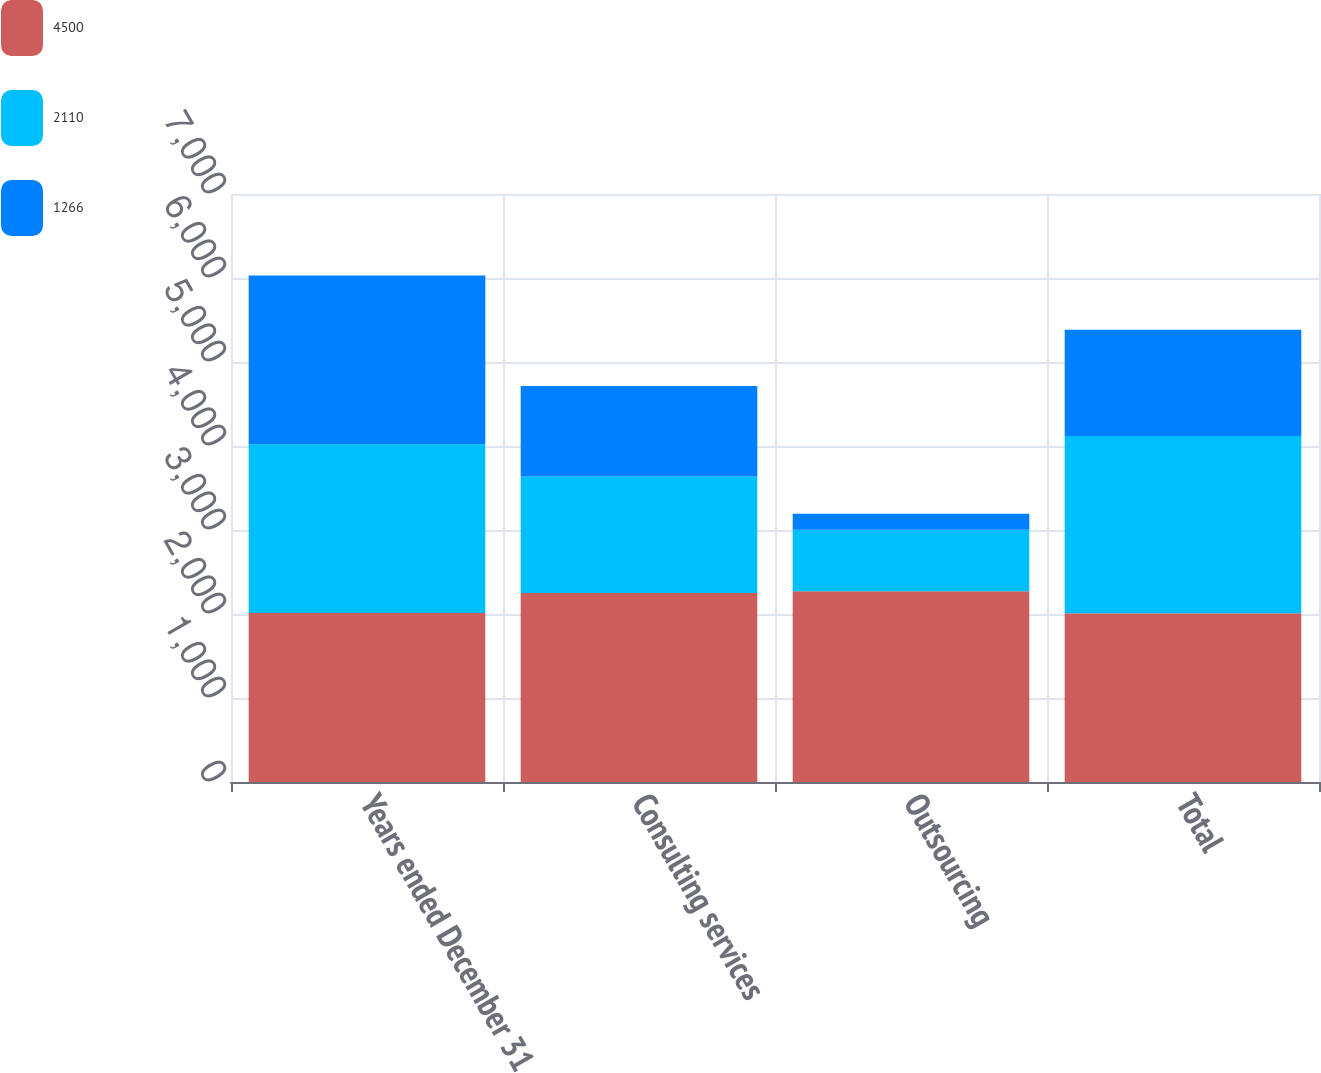Convert chart to OTSL. <chart><loc_0><loc_0><loc_500><loc_500><stacked_bar_chart><ecel><fcel>Years ended December 31<fcel>Consulting services<fcel>Outsourcing<fcel>Total<nl><fcel>4500<fcel>2011<fcel>2251<fcel>2272<fcel>2009<nl><fcel>2110<fcel>2010<fcel>1387<fcel>731<fcel>2110<nl><fcel>1266<fcel>2009<fcel>1075<fcel>191<fcel>1266<nl></chart> 